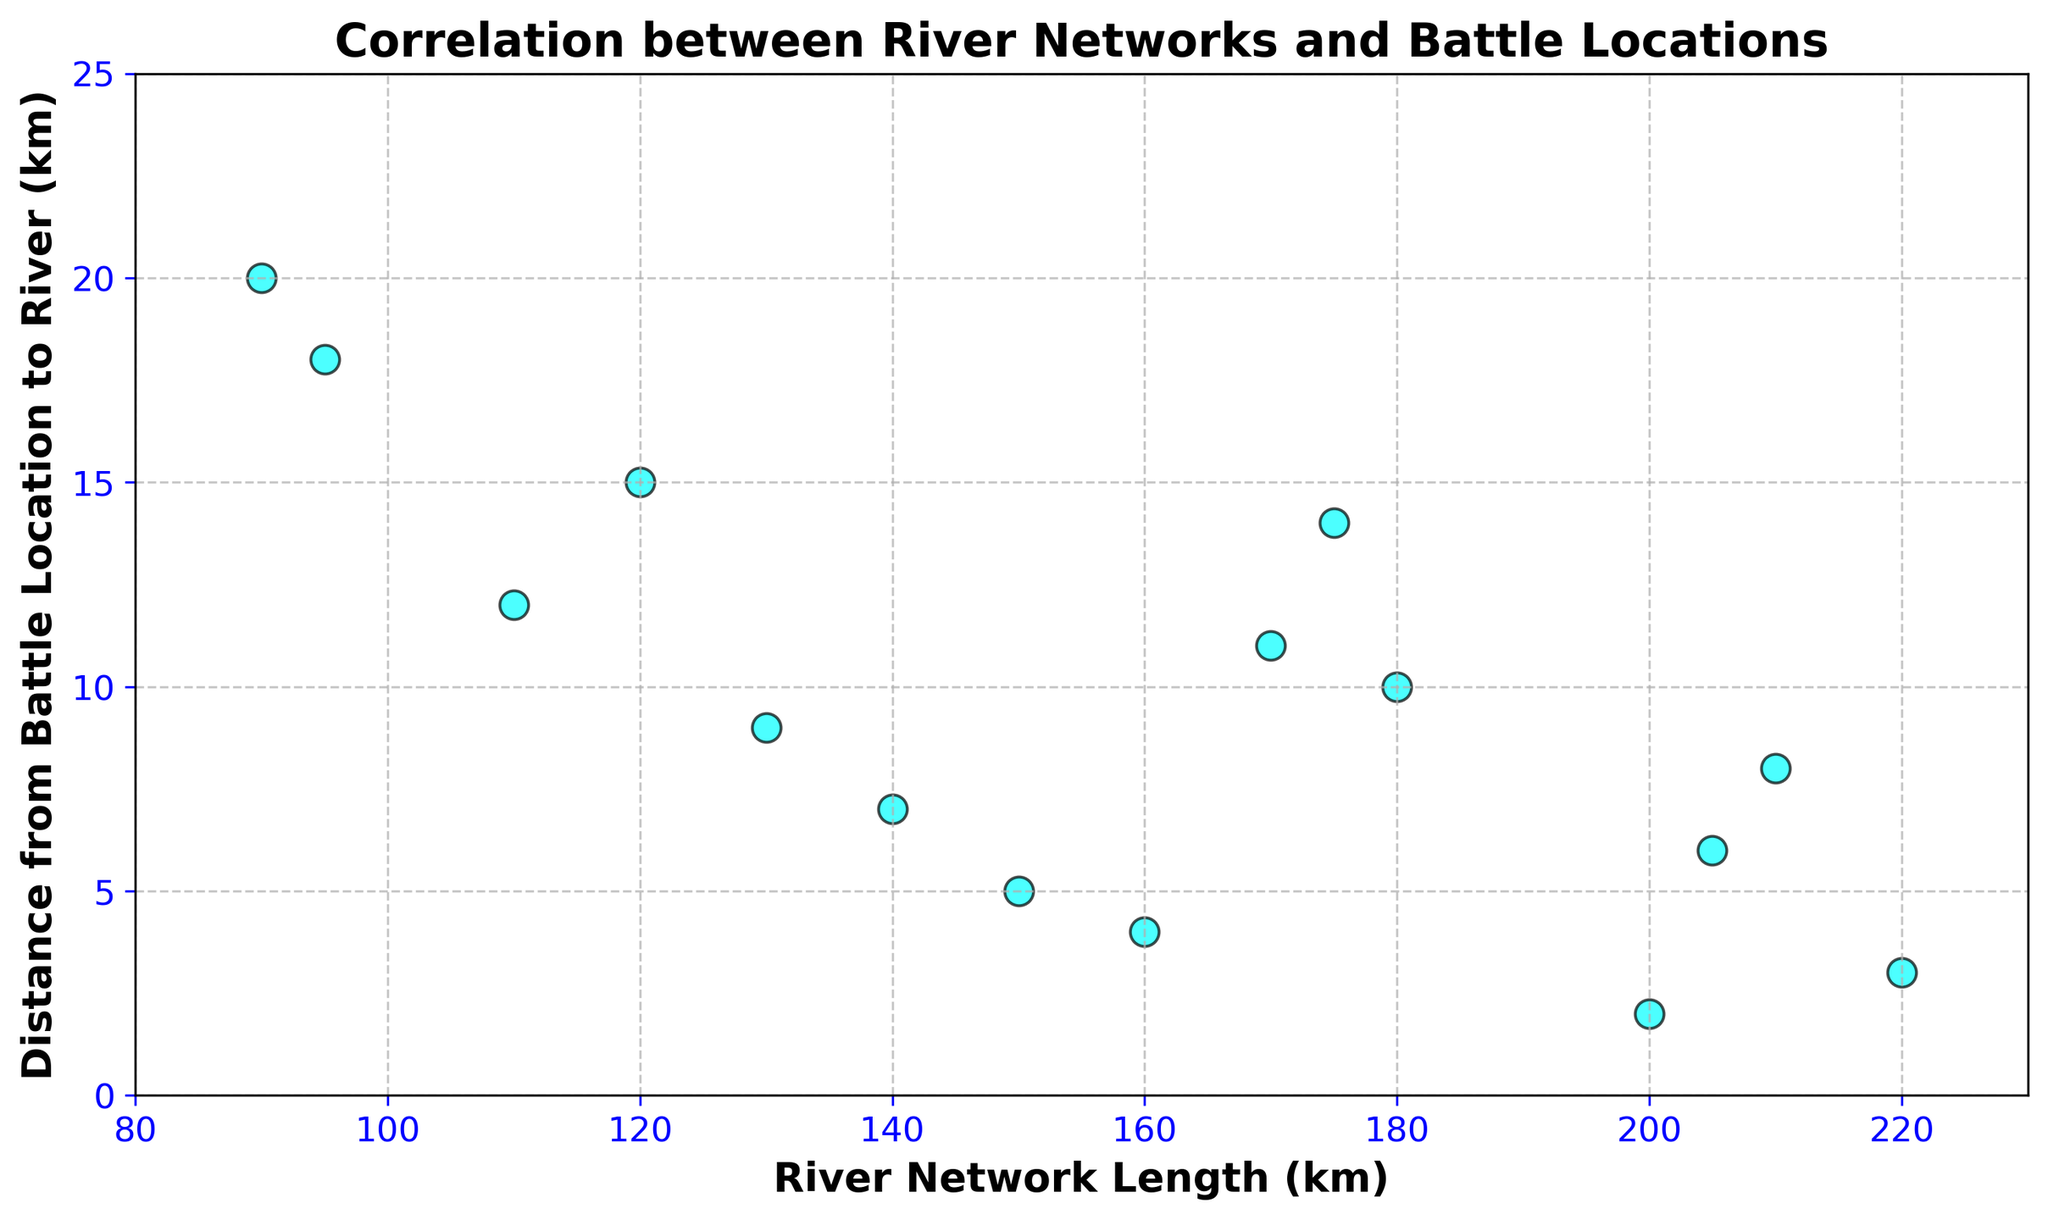What is the approximate relationship between river network length and battle location distance from the river? To understand the relationship, observe the scatter plot points' distribution. Generally, as the river network length increases, the distance from battle location to river decreases, indicating a negative correlation.
Answer: Negative correlation Which battle location is the furthest from a river? Look for the point with the highest y-axis value. The point at (90, 20) indicates the battle location that is 20 km from the river.
Answer: The battle location at 90 km river network length How many battle locations fall within 5 km of a river? Identify the points where the y-axis value is 5 or less. There are 5 points at (150, 5), (200, 2), (160, 4), (220, 3), and (205, 6).
Answer: 5 battle locations Which point has the highest river network length and what is its distance from the river? Look for the point with the highest x-value and find the corresponding y-value. The point (220, 3) has the highest river network length with a distance of 3 km from the river.
Answer: (220, 3) Are there any battle locations exactly 10 km from the river? If so, what are their river network lengths? Look for points where the y-value is 10. The point (180, 10) meets this criterion.
Answer: 180 km river network length How many battle locations are farther than 10 km from the river? Identify and count points where the y-axis value is greater than 10. There are 5 points at (120, 15), (90, 20), (110, 12), (95, 18), and (175, 14).
Answer: 5 battle locations Which river network length has the closest battle location to the river, and what is the distance? Identify the y-value that is the smallest, then note the corresponding x-value. The smallest y-value is 2, at the point (200, 2).
Answer: (200, 2) Calculate the average distance from the river for battle locations with a river network length of at least 160 km. Identify points where x ≥ 160, then sum their y-values and divide by the number of points. (160, 4), (200, 2), (180, 10), (220, 3), (210, 8), (170, 11), (205, 6), and (175, 14) are the points. Sum of y-values: 4 + 2 + 10 + 3 + 8 + 11 + 6 + 14 = 58. Average is 58/8 = 7.25.
Answer: 7.25 km Is there a river network length that appears more than once in the dataset? If yes, identify the distance values for those points. Review the x-values in the dataset for repeats. No river network length appears more than once.
Answer: No What is the median distance from the river for all battle locations? Order the y-axis values: 2, 3, 4, 5, 6, 7, 8, 9, 10, 11, 12, 14, 15, 18, 20. The middle value (8th value) in this ordered list is median: 10.
Answer: 10 km 